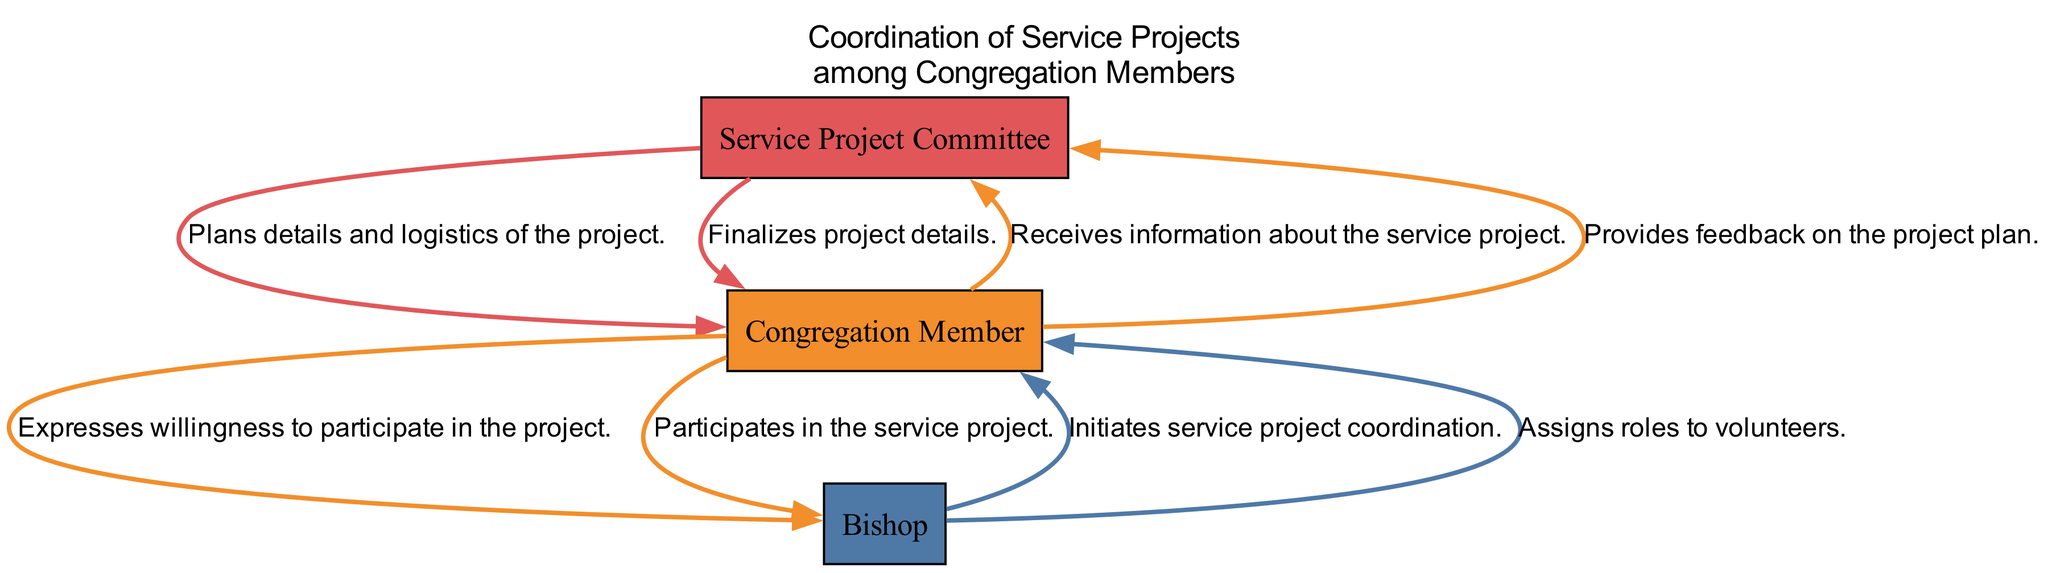What is the first action in the sequence? The first action in the sequence is performed by the Bishop, who initiates service project coordination.
Answer: Initiates service project coordination How many nodes are in the diagram? The diagram has three unique participants: the Bishop, Congregation Member, and Service Project Committee, making a total of three nodes.
Answer: Three Who provides feedback on the project plan? A Congregation Member provides feedback on the project plan as indicated by the relevant action in the sequence.
Answer: Congregation Member What is the last action performed in the sequence? The last action depicted in the sequence is conducted by the Bishop, who conducts follow-up after project completion.
Answer: Conducts follow-up after project completion Which participant assigns roles to volunteers? The participant who assigns roles to volunteers in the diagram is the Bishop.
Answer: Bishop Which two participants are involved in planning the service project? The two participants involved in planning the service project are the Service Project Committee and the Bishop, as they are responsible for coordinating the project's details.
Answer: Service Project Committee, Bishop How many actions does the first Congregation Member perform? The first Congregation Member performs two actions: receiving information about the service project and expressing willingness to participate.
Answer: Two actions Which member participates in the service project? The action of participating in the service project is performed by a Congregation Member as represented in the sequence.
Answer: Congregation Member Which action comes directly after the Service Project Committee finalizes project details? After the Service Project Committee finalizes the project details, a Congregation Member participates in the service project.
Answer: Participates in the service project 